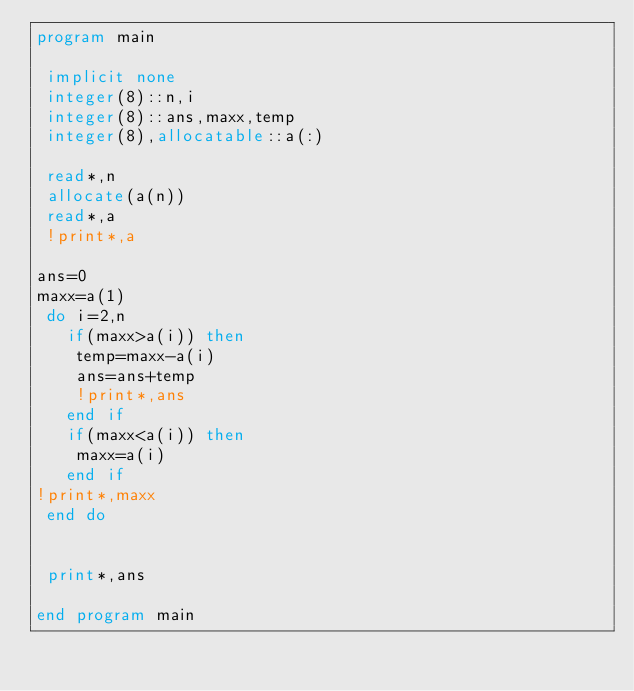<code> <loc_0><loc_0><loc_500><loc_500><_FORTRAN_>program main

 implicit none
 integer(8)::n,i
 integer(8)::ans,maxx,temp
 integer(8),allocatable::a(:)
 
 read*,n
 allocate(a(n))
 read*,a
 !print*,a

ans=0
maxx=a(1)
 do i=2,n
   if(maxx>a(i)) then
    temp=maxx-a(i)
    ans=ans+temp
    !print*,ans
   end if
   if(maxx<a(i)) then
    maxx=a(i)
   end if
!print*,maxx
 end do


 print*,ans

end program main</code> 